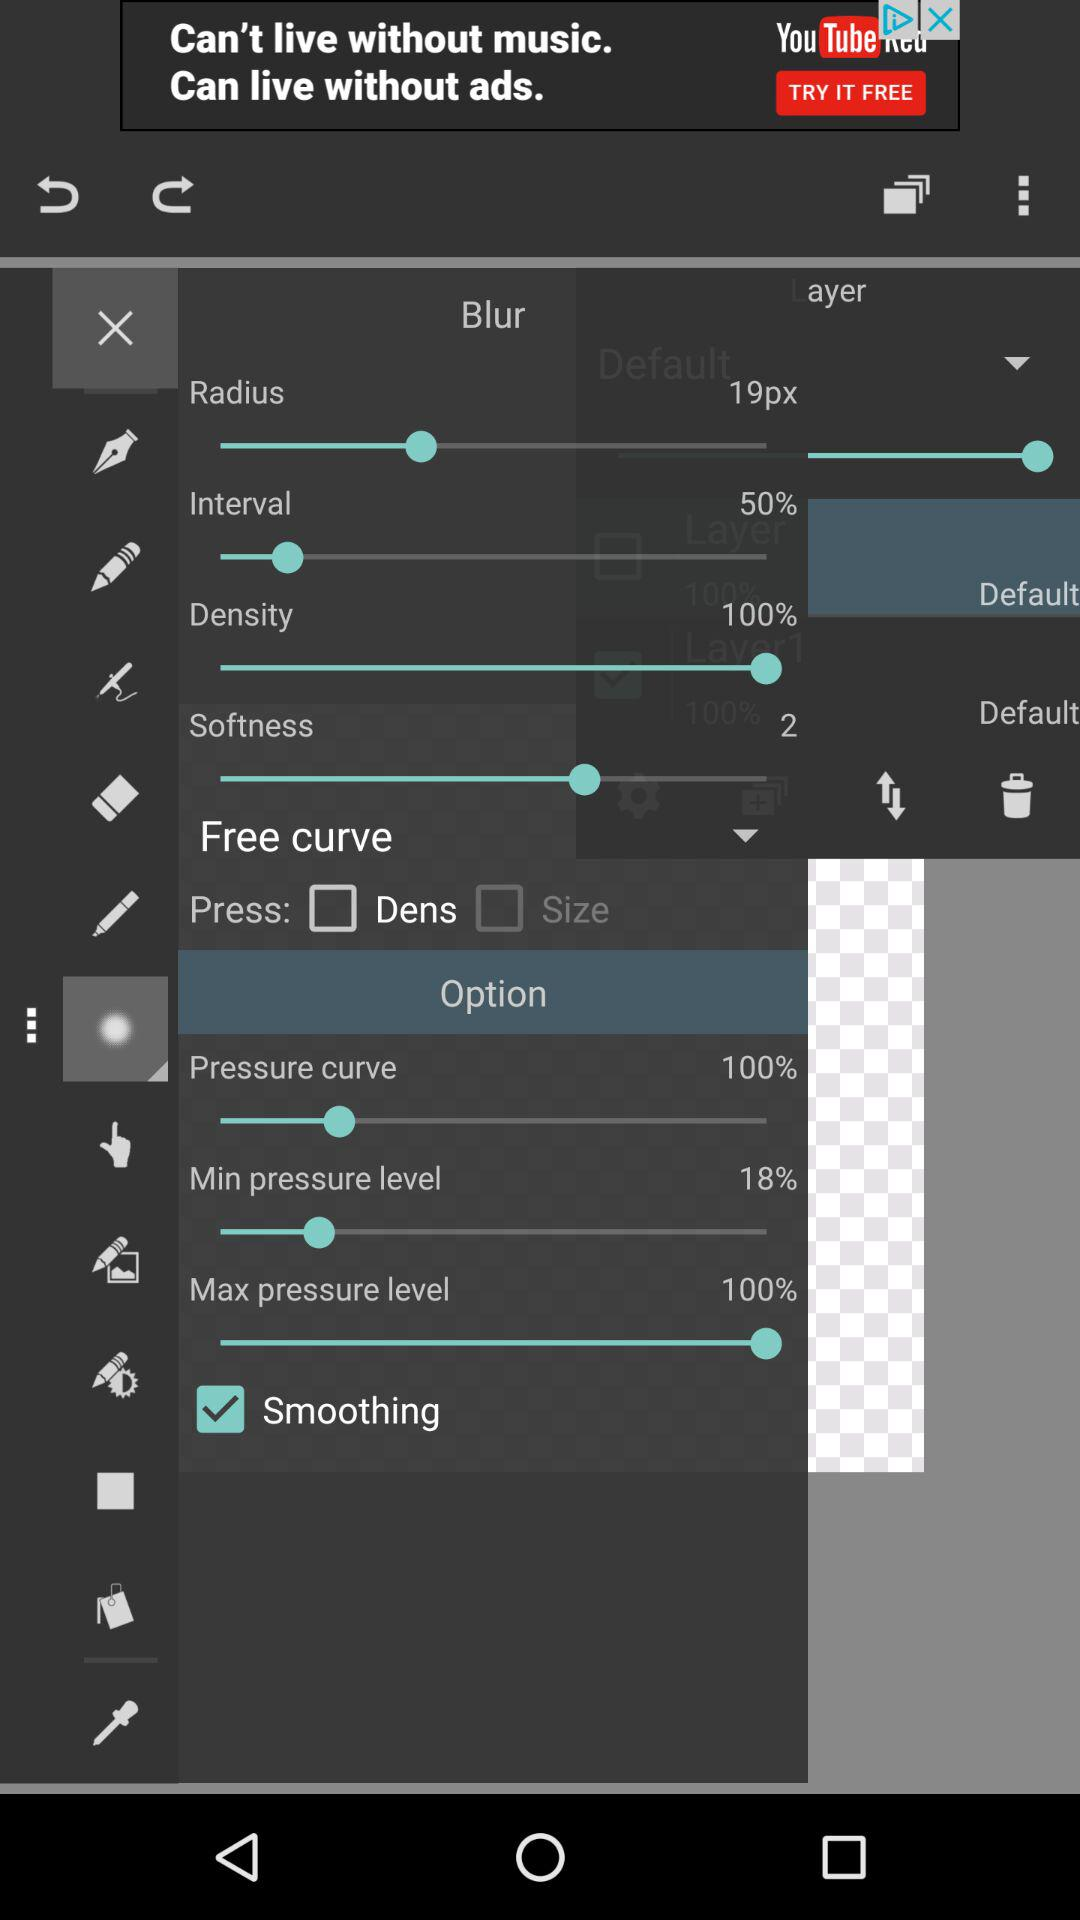What is the given percentage for density? The given percentage is 100. 